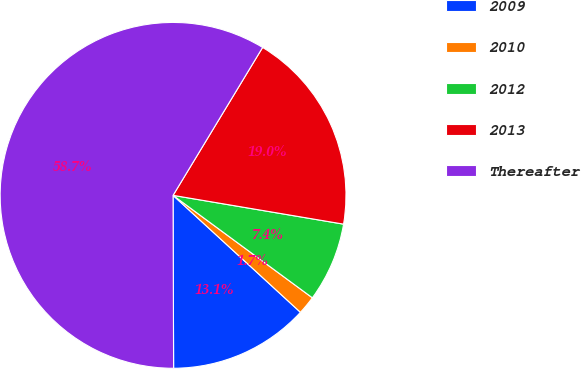<chart> <loc_0><loc_0><loc_500><loc_500><pie_chart><fcel>2009<fcel>2010<fcel>2012<fcel>2013<fcel>Thereafter<nl><fcel>13.13%<fcel>1.73%<fcel>7.43%<fcel>19.0%<fcel>58.72%<nl></chart> 